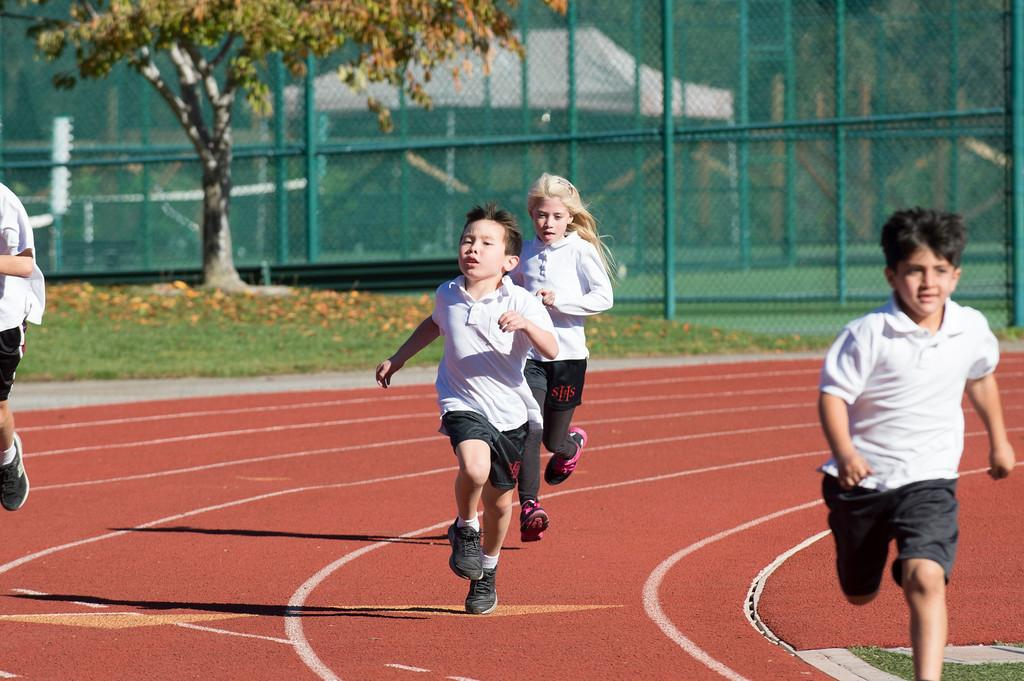What are the people in the image doing? The people in the image are running on a path. What can be seen on the ground in the image? The ground in the image has grass. What type of vegetation is present in the image? There is a tree in the image. What structures can be seen in the image? There are poles and a shed in the image. What might be used for playing a game in the image? There is a net in the image, which could be used for playing a game. What type of whip can be seen in the hands of the people running in the image? There is no whip present in the image; the people are running without any visible whips. 